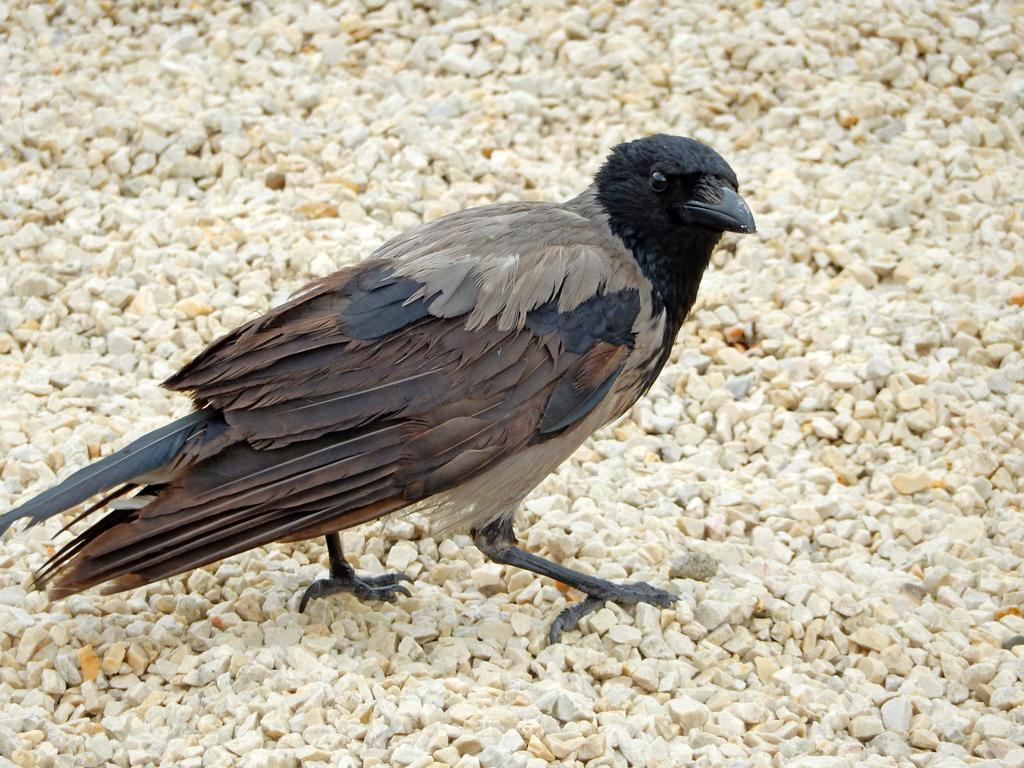Describe this image in one or two sentences. In the center of the image we can see a bird. At the bottom there are stones. 